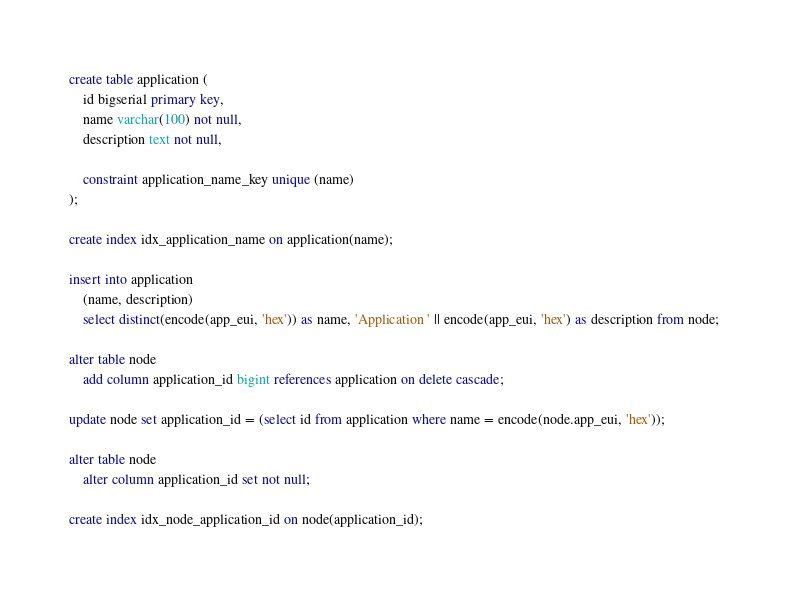Convert code to text. <code><loc_0><loc_0><loc_500><loc_500><_SQL_>create table application (
	id bigserial primary key,
	name varchar(100) not null,
	description text not null,

	constraint application_name_key unique (name)
);

create index idx_application_name on application(name);

insert into application
	(name, description)
	select distinct(encode(app_eui, 'hex')) as name, 'Application ' || encode(app_eui, 'hex') as description from node;

alter table node 
	add column application_id bigint references application on delete cascade;

update node set application_id = (select id from application where name = encode(node.app_eui, 'hex'));

alter table node 
	alter column application_id set not null;

create index idx_node_application_id on node(application_id);
</code> 